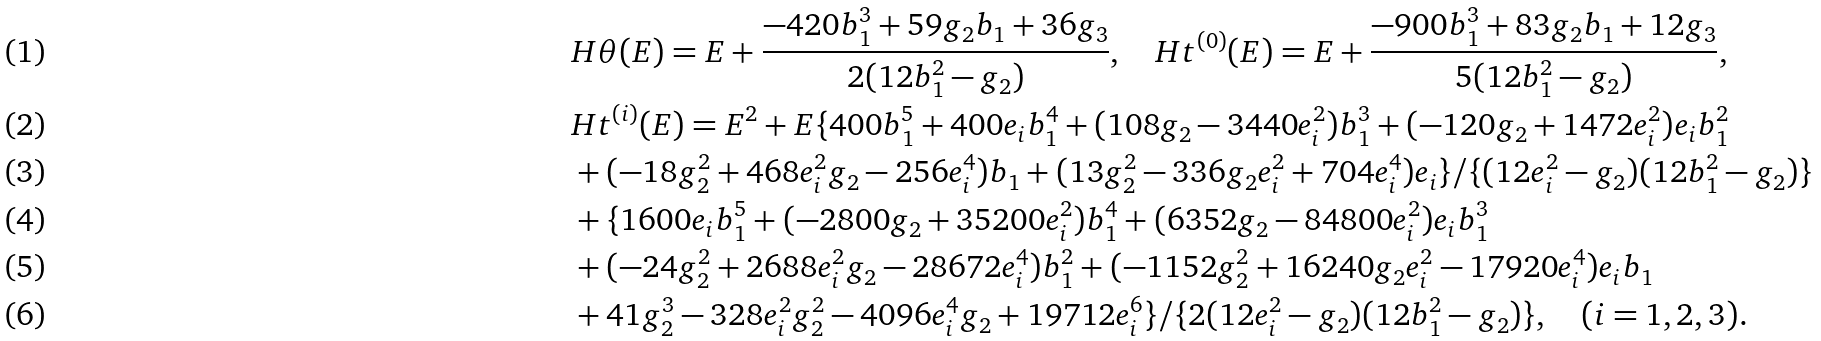<formula> <loc_0><loc_0><loc_500><loc_500>& H \theta ( E ) = E + \frac { - 4 2 0 b _ { 1 } ^ { 3 } + 5 9 g _ { 2 } b _ { 1 } + 3 6 g _ { 3 } } { 2 ( 1 2 b _ { 1 } ^ { 2 } - g _ { 2 } ) } , \quad H t ^ { ( 0 ) } ( E ) = E + \frac { - 9 0 0 b _ { 1 } ^ { 3 } + 8 3 g _ { 2 } b _ { 1 } + 1 2 g _ { 3 } } { 5 ( 1 2 b _ { 1 } ^ { 2 } - g _ { 2 } ) } , \\ & H t ^ { ( i ) } ( E ) = E ^ { 2 } + E \{ 4 0 0 b _ { 1 } ^ { 5 } + 4 0 0 e _ { i } b _ { 1 } ^ { 4 } + ( 1 0 8 g _ { 2 } - 3 4 4 0 e _ { i } ^ { 2 } ) b _ { 1 } ^ { 3 } + ( - 1 2 0 g _ { 2 } + 1 4 7 2 e _ { i } ^ { 2 } ) e _ { i } b _ { 1 } ^ { 2 } \\ & + ( - 1 8 g _ { 2 } ^ { 2 } + 4 6 8 e _ { i } ^ { 2 } g _ { 2 } - 2 5 6 e _ { i } ^ { 4 } ) b _ { 1 } + ( 1 3 g _ { 2 } ^ { 2 } - 3 3 6 g _ { 2 } e _ { i } ^ { 2 } + 7 0 4 e _ { i } ^ { 4 } ) e _ { i } \} / \{ ( 1 2 e _ { i } ^ { 2 } - g _ { 2 } ) ( 1 2 b _ { 1 } ^ { 2 } - g _ { 2 } ) \} \\ & + \{ 1 6 0 0 e _ { i } b _ { 1 } ^ { 5 } + ( - 2 8 0 0 g _ { 2 } + 3 5 2 0 0 e _ { i } ^ { 2 } ) b _ { 1 } ^ { 4 } + ( 6 3 5 2 g _ { 2 } - 8 4 8 0 0 e _ { i } ^ { 2 } ) e _ { i } b _ { 1 } ^ { 3 } \\ & + ( - 2 4 g _ { 2 } ^ { 2 } + 2 6 8 8 e _ { i } ^ { 2 } g _ { 2 } - 2 8 6 7 2 e _ { i } ^ { 4 } ) b _ { 1 } ^ { 2 } + ( - 1 1 5 2 g _ { 2 } ^ { 2 } + 1 6 2 4 0 g _ { 2 } e _ { i } ^ { 2 } - 1 7 9 2 0 e _ { i } ^ { 4 } ) e _ { i } b _ { 1 } \\ & + 4 1 g _ { 2 } ^ { 3 } - 3 2 8 e _ { i } ^ { 2 } g _ { 2 } ^ { 2 } - 4 0 9 6 e _ { i } ^ { 4 } g _ { 2 } + 1 9 7 1 2 e _ { i } ^ { 6 } \} / \{ 2 ( 1 2 e _ { i } ^ { 2 } - g _ { 2 } ) ( 1 2 b _ { 1 } ^ { 2 } - g _ { 2 } ) \} , \quad ( i = 1 , 2 , 3 ) .</formula> 